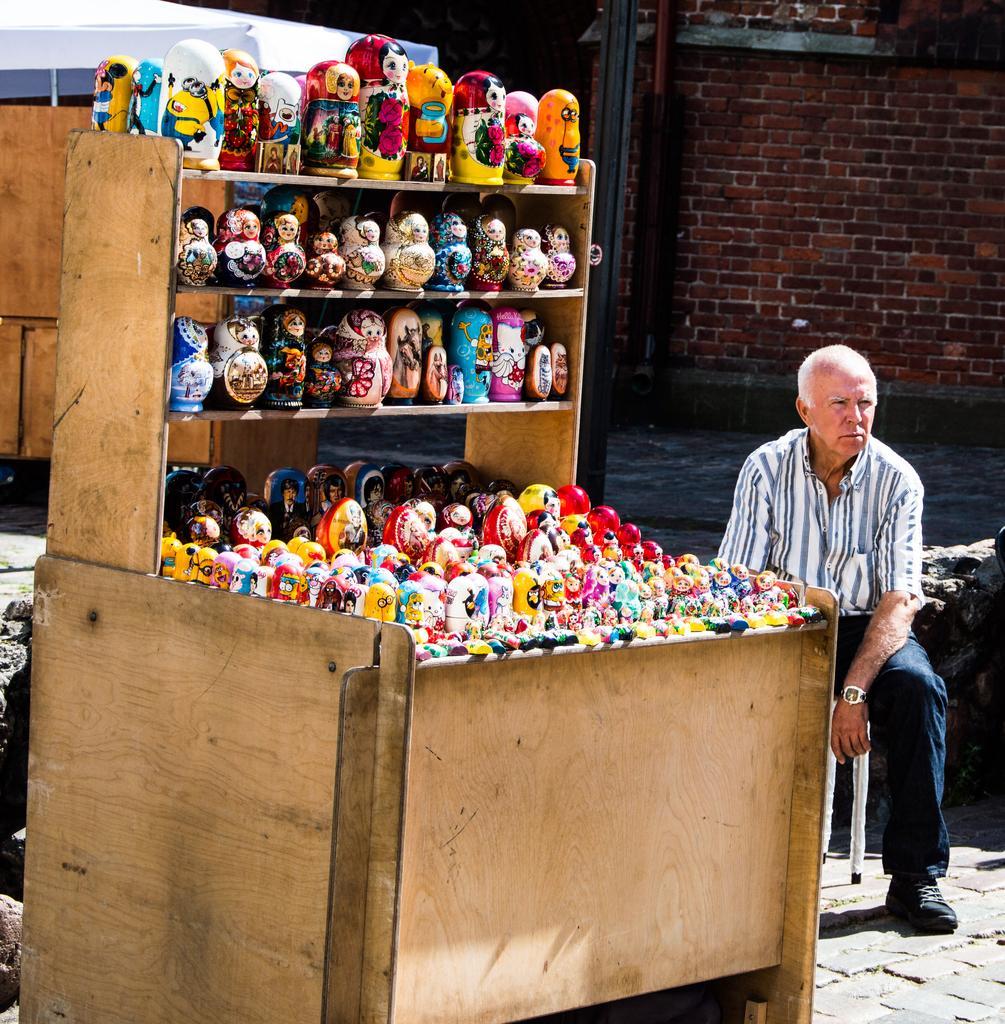Can you describe this image briefly? In the picture we can see a table with rack to it and it is filled up with many dolls and beside it, we can see a man sitting on the stool and behind him we can see the wall with bricks. 